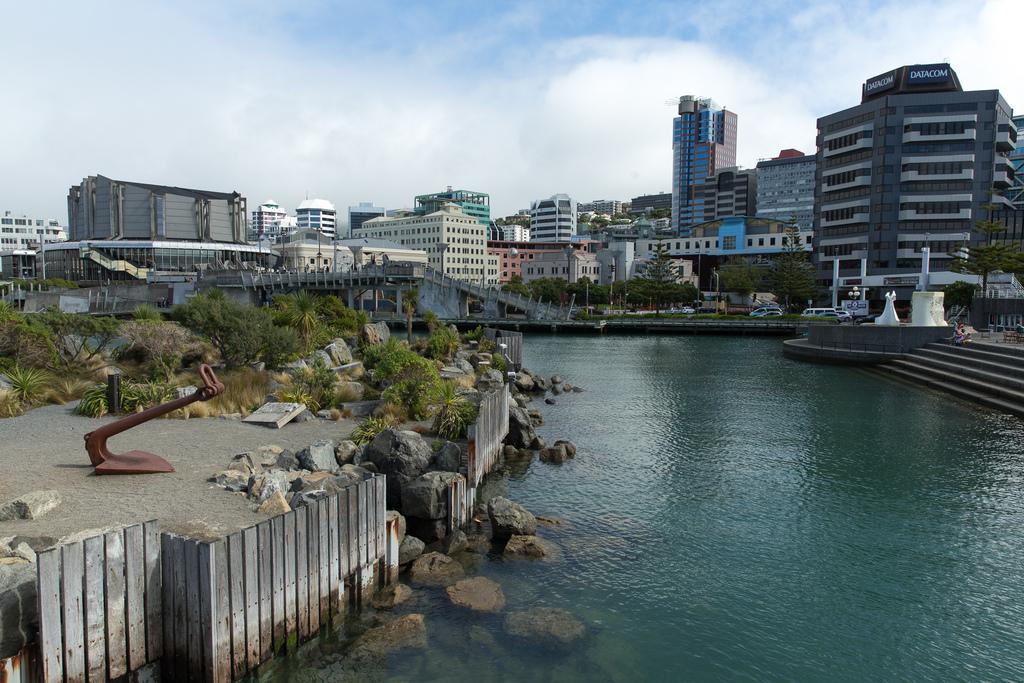In one or two sentences, can you explain what this image depicts? In this image I can see water, few stones, trees and grass in green color. Background I can see few buildings in white, gray and blue color, few vehicles and the sky is in blue and white color. 